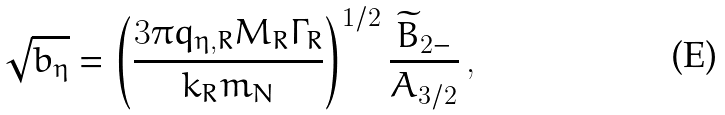Convert formula to latex. <formula><loc_0><loc_0><loc_500><loc_500>\sqrt { b _ { \eta } } = \left ( \frac { 3 \pi q _ { \eta , R } M _ { R } \Gamma _ { R } } { k _ { R } m _ { N } } \right ) ^ { 1 / 2 } \frac { \widetilde { B } _ { 2 - } } { A _ { 3 / 2 } } \, ,</formula> 